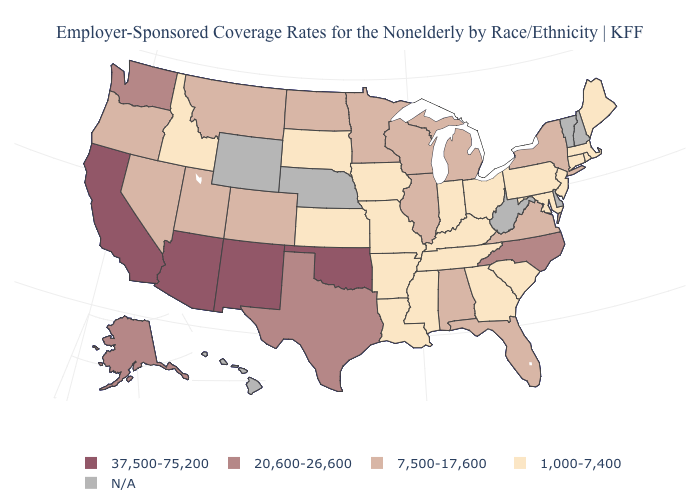How many symbols are there in the legend?
Concise answer only. 5. What is the value of Oregon?
Short answer required. 7,500-17,600. Does the first symbol in the legend represent the smallest category?
Keep it brief. No. Among the states that border Washington , which have the highest value?
Short answer required. Oregon. What is the value of Nevada?
Keep it brief. 7,500-17,600. Among the states that border Massachusetts , which have the lowest value?
Write a very short answer. Connecticut, Rhode Island. Does the map have missing data?
Keep it brief. Yes. Which states have the lowest value in the West?
Concise answer only. Idaho. What is the highest value in the USA?
Give a very brief answer. 37,500-75,200. What is the highest value in the South ?
Concise answer only. 37,500-75,200. Does Alaska have the lowest value in the USA?
Give a very brief answer. No. What is the lowest value in the USA?
Write a very short answer. 1,000-7,400. Among the states that border Tennessee , does Alabama have the highest value?
Concise answer only. No. Name the states that have a value in the range 37,500-75,200?
Concise answer only. Arizona, California, New Mexico, Oklahoma. Name the states that have a value in the range 37,500-75,200?
Answer briefly. Arizona, California, New Mexico, Oklahoma. 